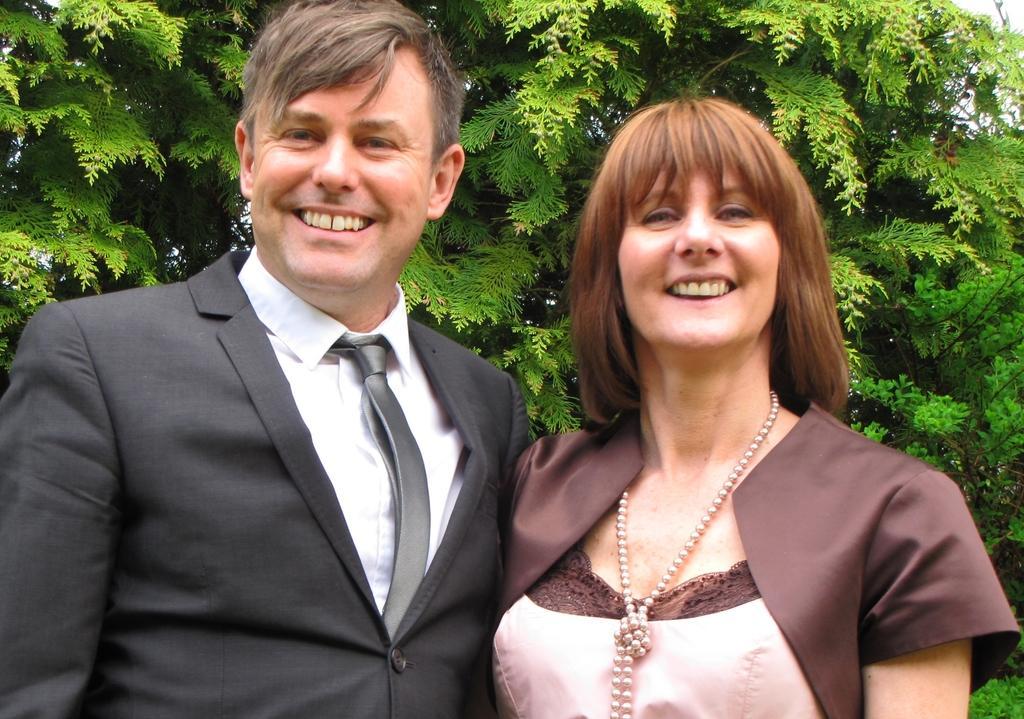Could you give a brief overview of what you see in this image? In this picture I can see there is a man and a woman standing, they are laughing and there are trees in the backdrop and the sky is clear. 